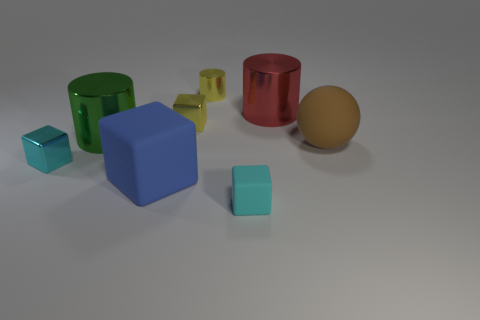Subtract all yellow blocks. How many blocks are left? 3 Subtract all cyan matte blocks. How many blocks are left? 3 Add 1 yellow rubber objects. How many objects exist? 9 Subtract all red blocks. Subtract all gray cylinders. How many blocks are left? 4 Subtract all spheres. How many objects are left? 7 Add 5 shiny things. How many shiny things exist? 10 Subtract 0 blue cylinders. How many objects are left? 8 Subtract all small yellow cubes. Subtract all matte cubes. How many objects are left? 5 Add 4 big blue things. How many big blue things are left? 5 